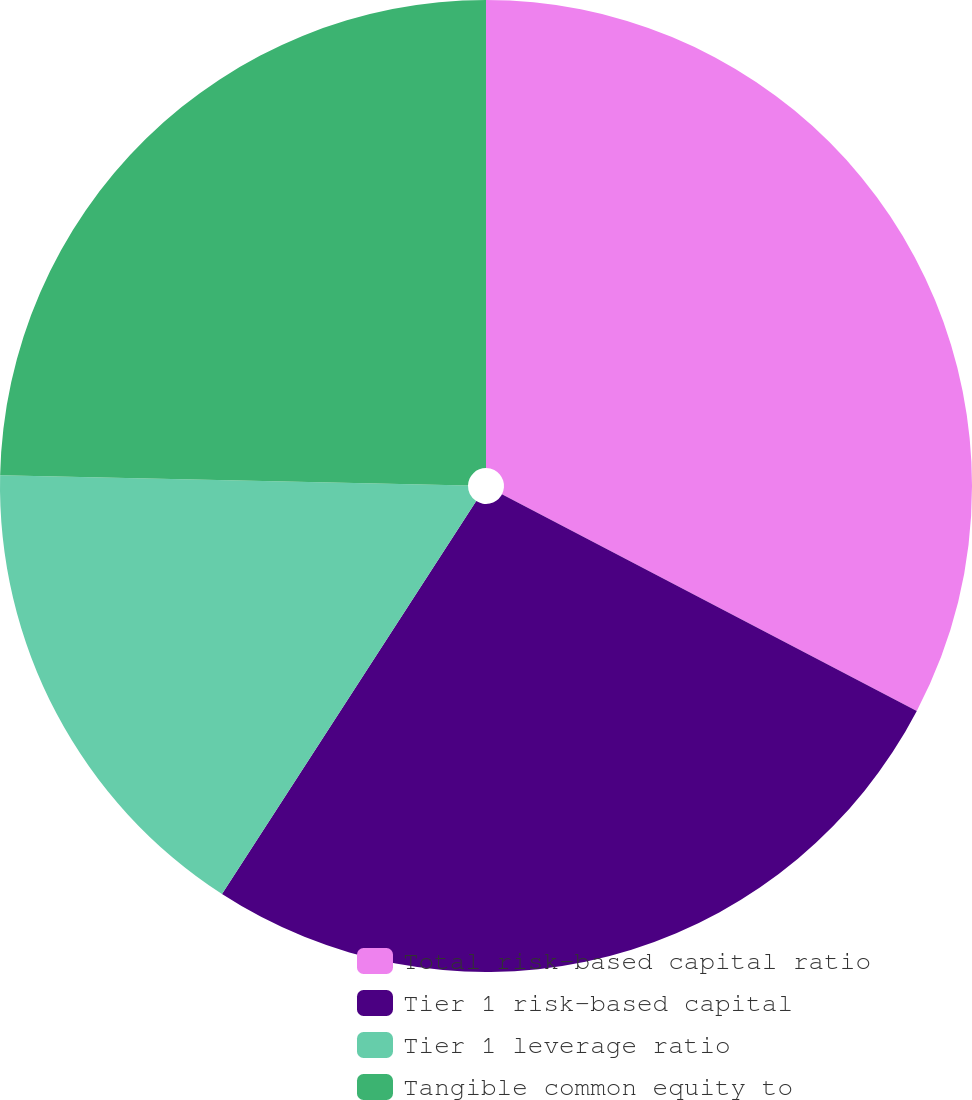Convert chart. <chart><loc_0><loc_0><loc_500><loc_500><pie_chart><fcel>Total risk-based capital ratio<fcel>Tier 1 risk-based capital<fcel>Tier 1 leverage ratio<fcel>Tangible common equity to<nl><fcel>32.66%<fcel>26.48%<fcel>16.21%<fcel>24.65%<nl></chart> 